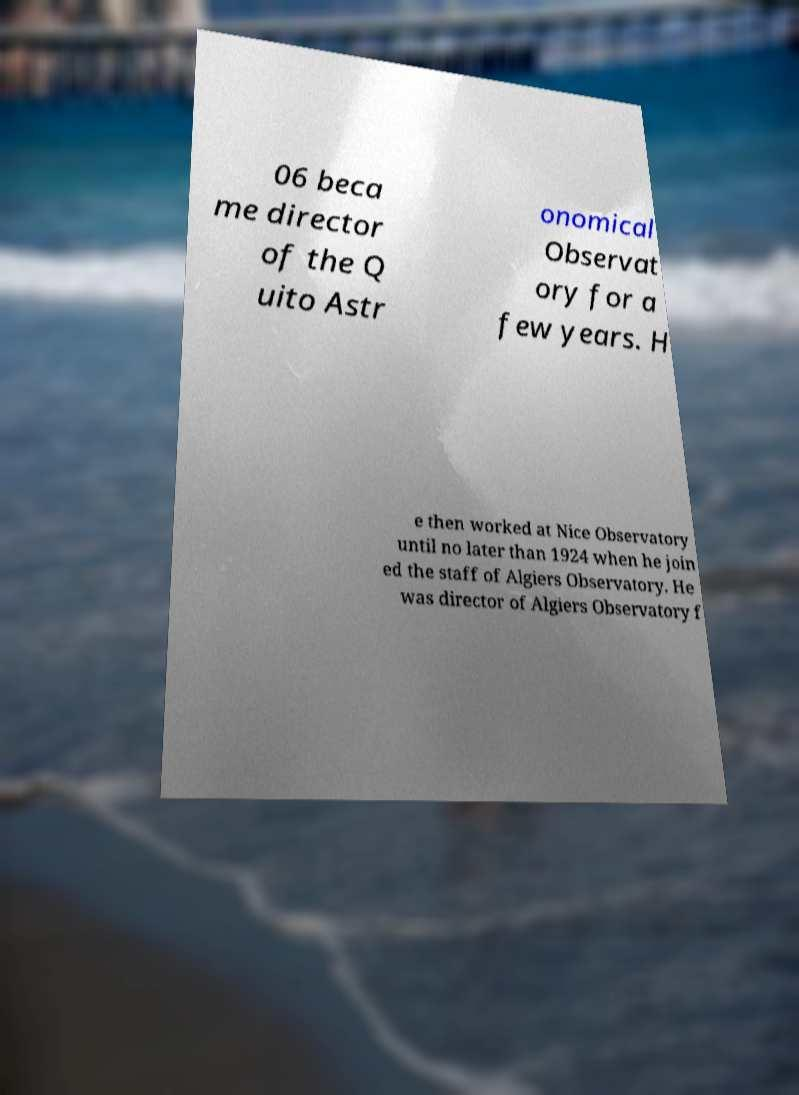For documentation purposes, I need the text within this image transcribed. Could you provide that? 06 beca me director of the Q uito Astr onomical Observat ory for a few years. H e then worked at Nice Observatory until no later than 1924 when he join ed the staff of Algiers Observatory. He was director of Algiers Observatory f 